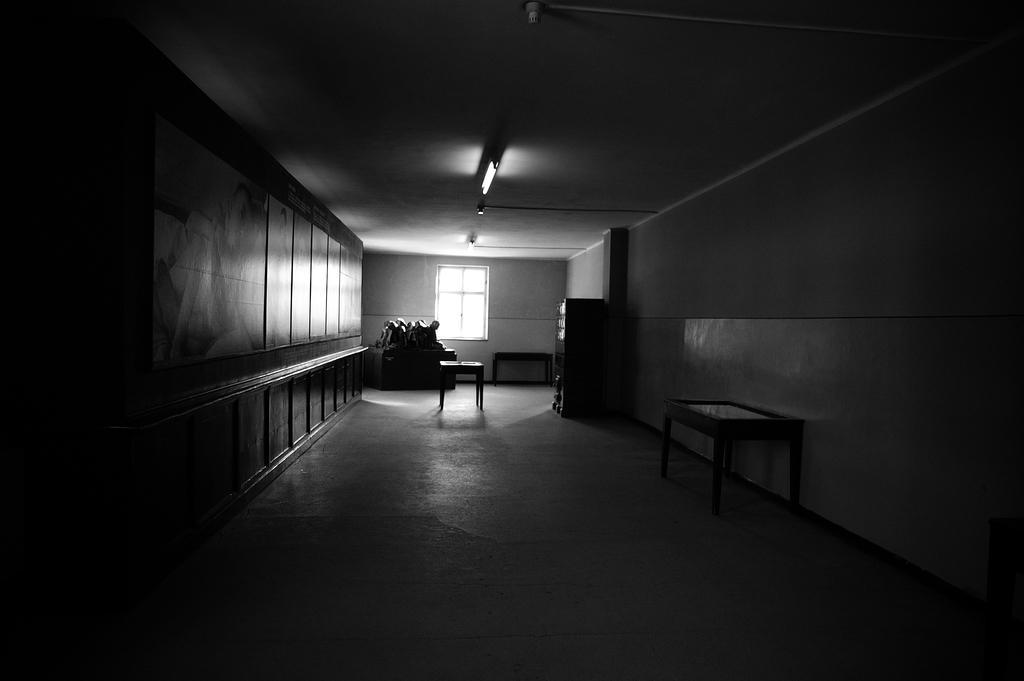Describe this image in one or two sentences. This image is clicked inside a building. On the right there are cupboards, table. On the left there are cupboards. In the middle there is a table, person, window and wall. At the top there is light. 